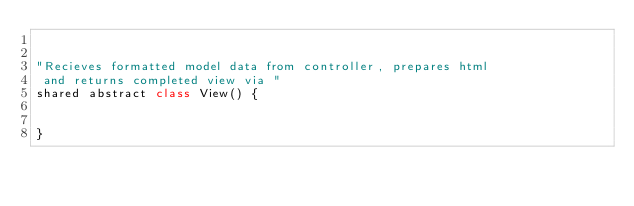<code> <loc_0><loc_0><loc_500><loc_500><_Ceylon_>

"Recieves formatted model data from controller, prepares html
 and returns completed view via "
shared abstract class View() {

	
}</code> 